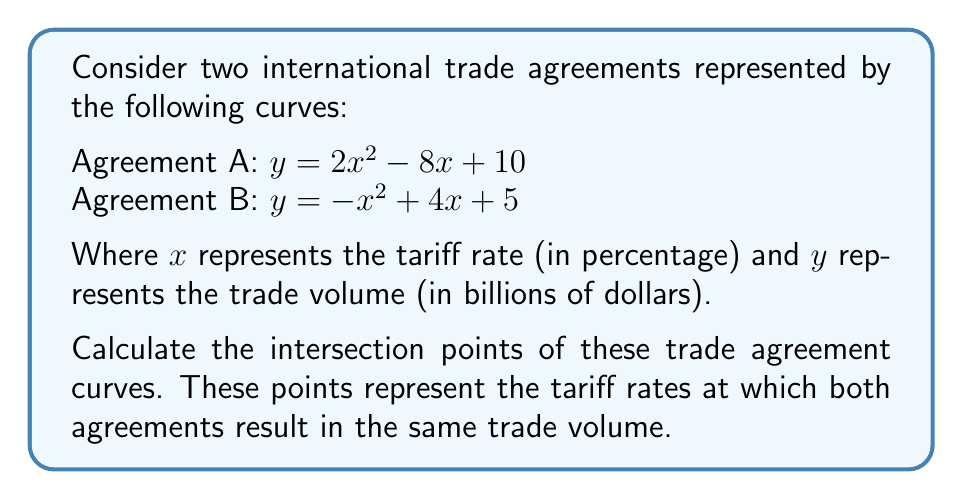Provide a solution to this math problem. To find the intersection points, we need to solve the equation where both curves are equal:

1) Set the equations equal to each other:
   $2x^2 - 8x + 10 = -x^2 + 4x + 5$

2) Rearrange the equation to standard form:
   $2x^2 - 8x + 10 + x^2 - 4x - 5 = 0$
   $3x^2 - 12x + 5 = 0$

3) This is a quadratic equation in the form $ax^2 + bx + c = 0$, where:
   $a = 3$, $b = -12$, and $c = 5$

4) Use the quadratic formula: $x = \frac{-b \pm \sqrt{b^2 - 4ac}}{2a}$

5) Substitute the values:
   $x = \frac{12 \pm \sqrt{(-12)^2 - 4(3)(5)}}{2(3)}$
   $x = \frac{12 \pm \sqrt{144 - 60}}{6}$
   $x = \frac{12 \pm \sqrt{84}}{6}$
   $x = \frac{12 \pm 2\sqrt{21}}{6}$

6) Simplify:
   $x = 2 \pm \frac{\sqrt{21}}{3}$

7) Therefore, the two solutions are:
   $x_1 = 2 + \frac{\sqrt{21}}{3}$ and $x_2 = 2 - \frac{\sqrt{21}}{3}$

8) To find the corresponding y-values, substitute either x value into either original equation. Using Agreement A:

   For $x_1$: $y_1 = 2(2 + \frac{\sqrt{21}}{3})^2 - 8(2 + \frac{\sqrt{21}}{3}) + 10$
   For $x_2$: $y_2 = 2(2 - \frac{\sqrt{21}}{3})^2 - 8(2 - \frac{\sqrt{21}}{3}) + 10$

9) Simplify these expressions to get the final y-values.
Answer: $(\frac{6+\sqrt{21}}{3}, \frac{70-2\sqrt{21}}{3})$ and $(\frac{6-\sqrt{21}}{3}, \frac{70+2\sqrt{21}}{3})$ 